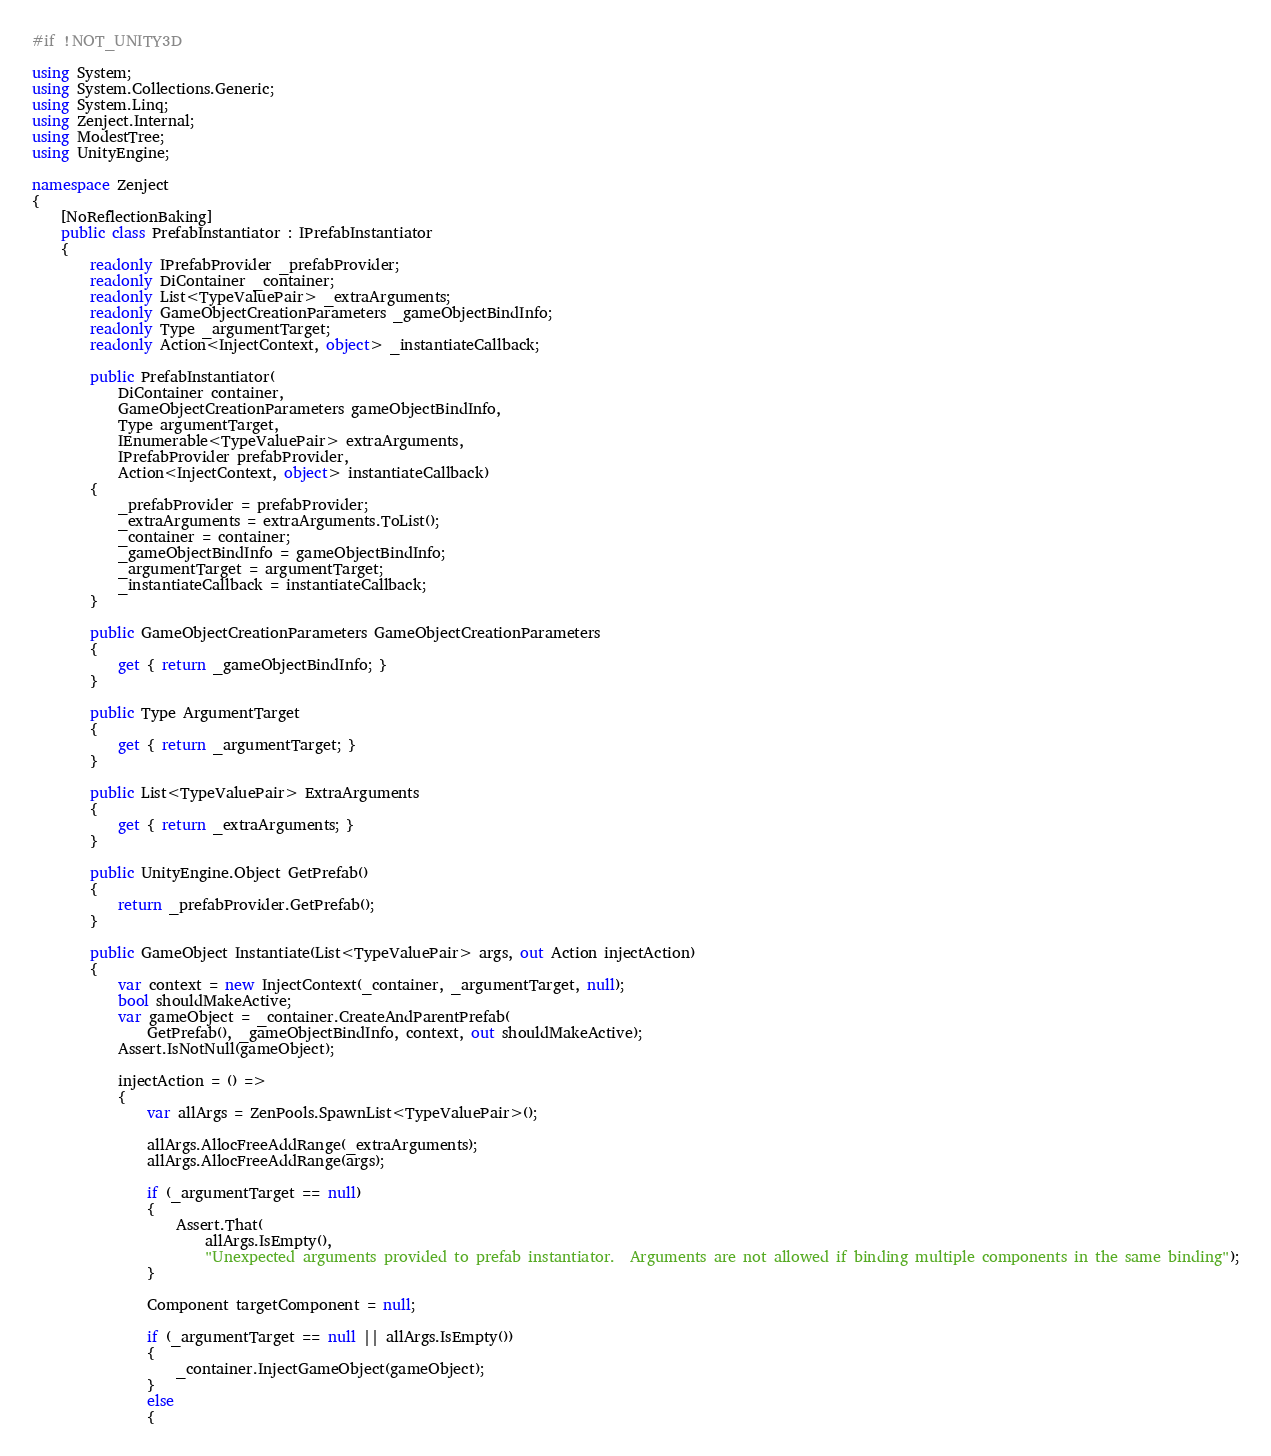Convert code to text. <code><loc_0><loc_0><loc_500><loc_500><_C#_>#if !NOT_UNITY3D

using System;
using System.Collections.Generic;
using System.Linq;
using Zenject.Internal;
using ModestTree;
using UnityEngine;

namespace Zenject
{
    [NoReflectionBaking]
    public class PrefabInstantiator : IPrefabInstantiator
    {
        readonly IPrefabProvider _prefabProvider;
        readonly DiContainer _container;
        readonly List<TypeValuePair> _extraArguments;
        readonly GameObjectCreationParameters _gameObjectBindInfo;
        readonly Type _argumentTarget;
        readonly Action<InjectContext, object> _instantiateCallback;

        public PrefabInstantiator(
            DiContainer container,
            GameObjectCreationParameters gameObjectBindInfo,
            Type argumentTarget,
            IEnumerable<TypeValuePair> extraArguments,
            IPrefabProvider prefabProvider,
            Action<InjectContext, object> instantiateCallback)
        {
            _prefabProvider = prefabProvider;
            _extraArguments = extraArguments.ToList();
            _container = container;
            _gameObjectBindInfo = gameObjectBindInfo;
            _argumentTarget = argumentTarget;
            _instantiateCallback = instantiateCallback;
        }

        public GameObjectCreationParameters GameObjectCreationParameters
        {
            get { return _gameObjectBindInfo; }
        }

        public Type ArgumentTarget
        {
            get { return _argumentTarget; }
        }

        public List<TypeValuePair> ExtraArguments
        {
            get { return _extraArguments; }
        }

        public UnityEngine.Object GetPrefab()
        {
            return _prefabProvider.GetPrefab();
        }

        public GameObject Instantiate(List<TypeValuePair> args, out Action injectAction)
        {
            var context = new InjectContext(_container, _argumentTarget, null);
            bool shouldMakeActive;
            var gameObject = _container.CreateAndParentPrefab(
                GetPrefab(), _gameObjectBindInfo, context, out shouldMakeActive);
            Assert.IsNotNull(gameObject);

            injectAction = () =>
            {
                var allArgs = ZenPools.SpawnList<TypeValuePair>();

                allArgs.AllocFreeAddRange(_extraArguments);
                allArgs.AllocFreeAddRange(args);

                if (_argumentTarget == null)
                {
                    Assert.That(
                        allArgs.IsEmpty(),
                        "Unexpected arguments provided to prefab instantiator.  Arguments are not allowed if binding multiple components in the same binding");
                }

                Component targetComponent = null;

                if (_argumentTarget == null || allArgs.IsEmpty())
                {
                    _container.InjectGameObject(gameObject);
                }
                else
                {</code> 